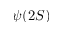Convert formula to latex. <formula><loc_0><loc_0><loc_500><loc_500>\psi ( 2 S )</formula> 